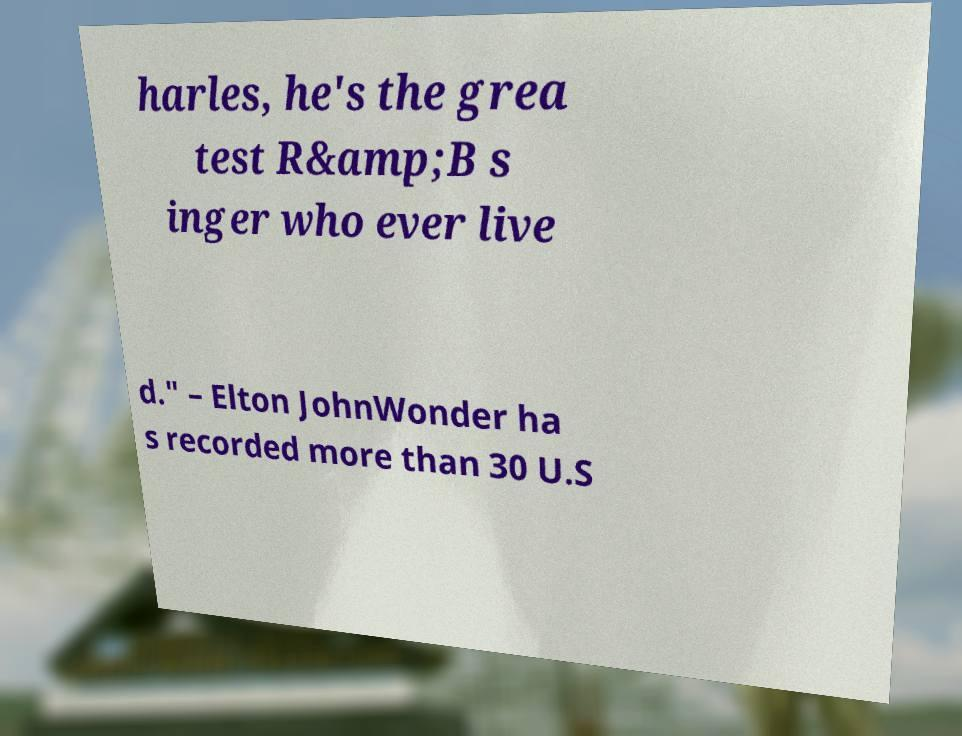For documentation purposes, I need the text within this image transcribed. Could you provide that? harles, he's the grea test R&amp;B s inger who ever live d." – Elton JohnWonder ha s recorded more than 30 U.S 